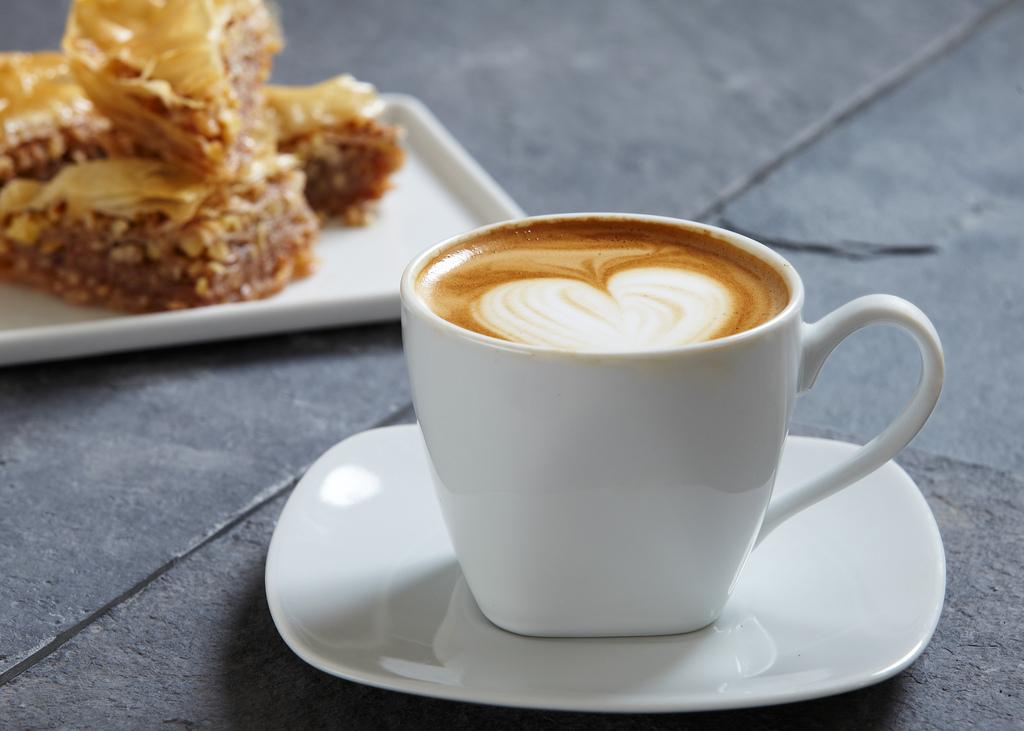What is located at the bottom of the image? There is a coffee cup and saucer in the image. Where is the plate with food located in the image? The plate is on the left side of the image. What type of juice is being served on the board in the image? There is no juice or board present in the image. 